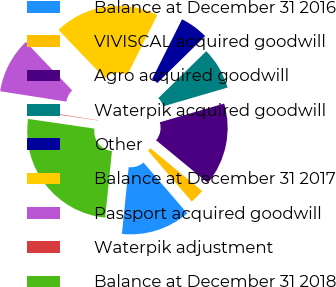Convert chart to OTSL. <chart><loc_0><loc_0><loc_500><loc_500><pie_chart><fcel>Balance at December 31 2016<fcel>VIVISCAL acquired goodwill<fcel>Agro acquired goodwill<fcel>Waterpik acquired goodwill<fcel>Other<fcel>Balance at December 31 2017<fcel>Passport acquired goodwill<fcel>Waterpik adjustment<fcel>Balance at December 31 2018<nl><fcel>12.93%<fcel>2.72%<fcel>15.48%<fcel>7.82%<fcel>5.27%<fcel>19.56%<fcel>10.37%<fcel>0.16%<fcel>25.7%<nl></chart> 